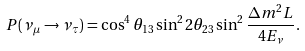Convert formula to latex. <formula><loc_0><loc_0><loc_500><loc_500>P ( \nu _ { \mu } \rightarrow \nu _ { \tau } ) = \cos ^ { 4 } \theta _ { 1 3 } \sin ^ { 2 } 2 \theta _ { 2 3 } \sin ^ { 2 } \frac { \Delta m ^ { 2 } L } { 4 E _ { \nu } } .</formula> 